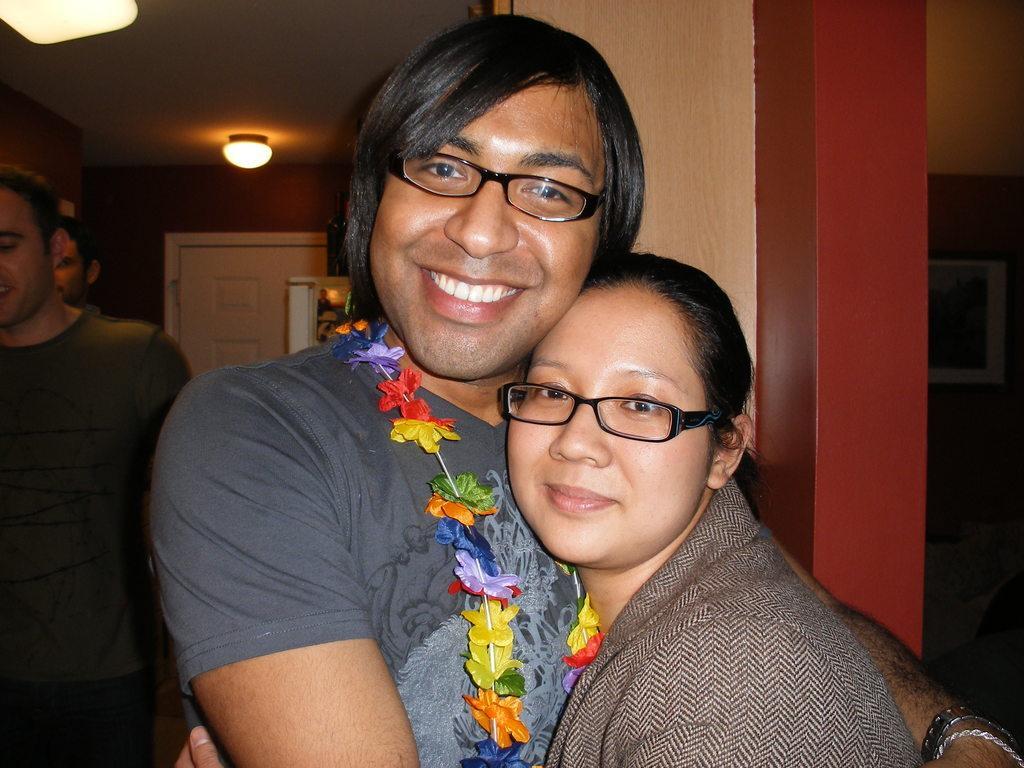How would you summarize this image in a sentence or two? This is the picture of a place where we have a lady and a guy holding each other and behind there are some other people and a light to the roof. 